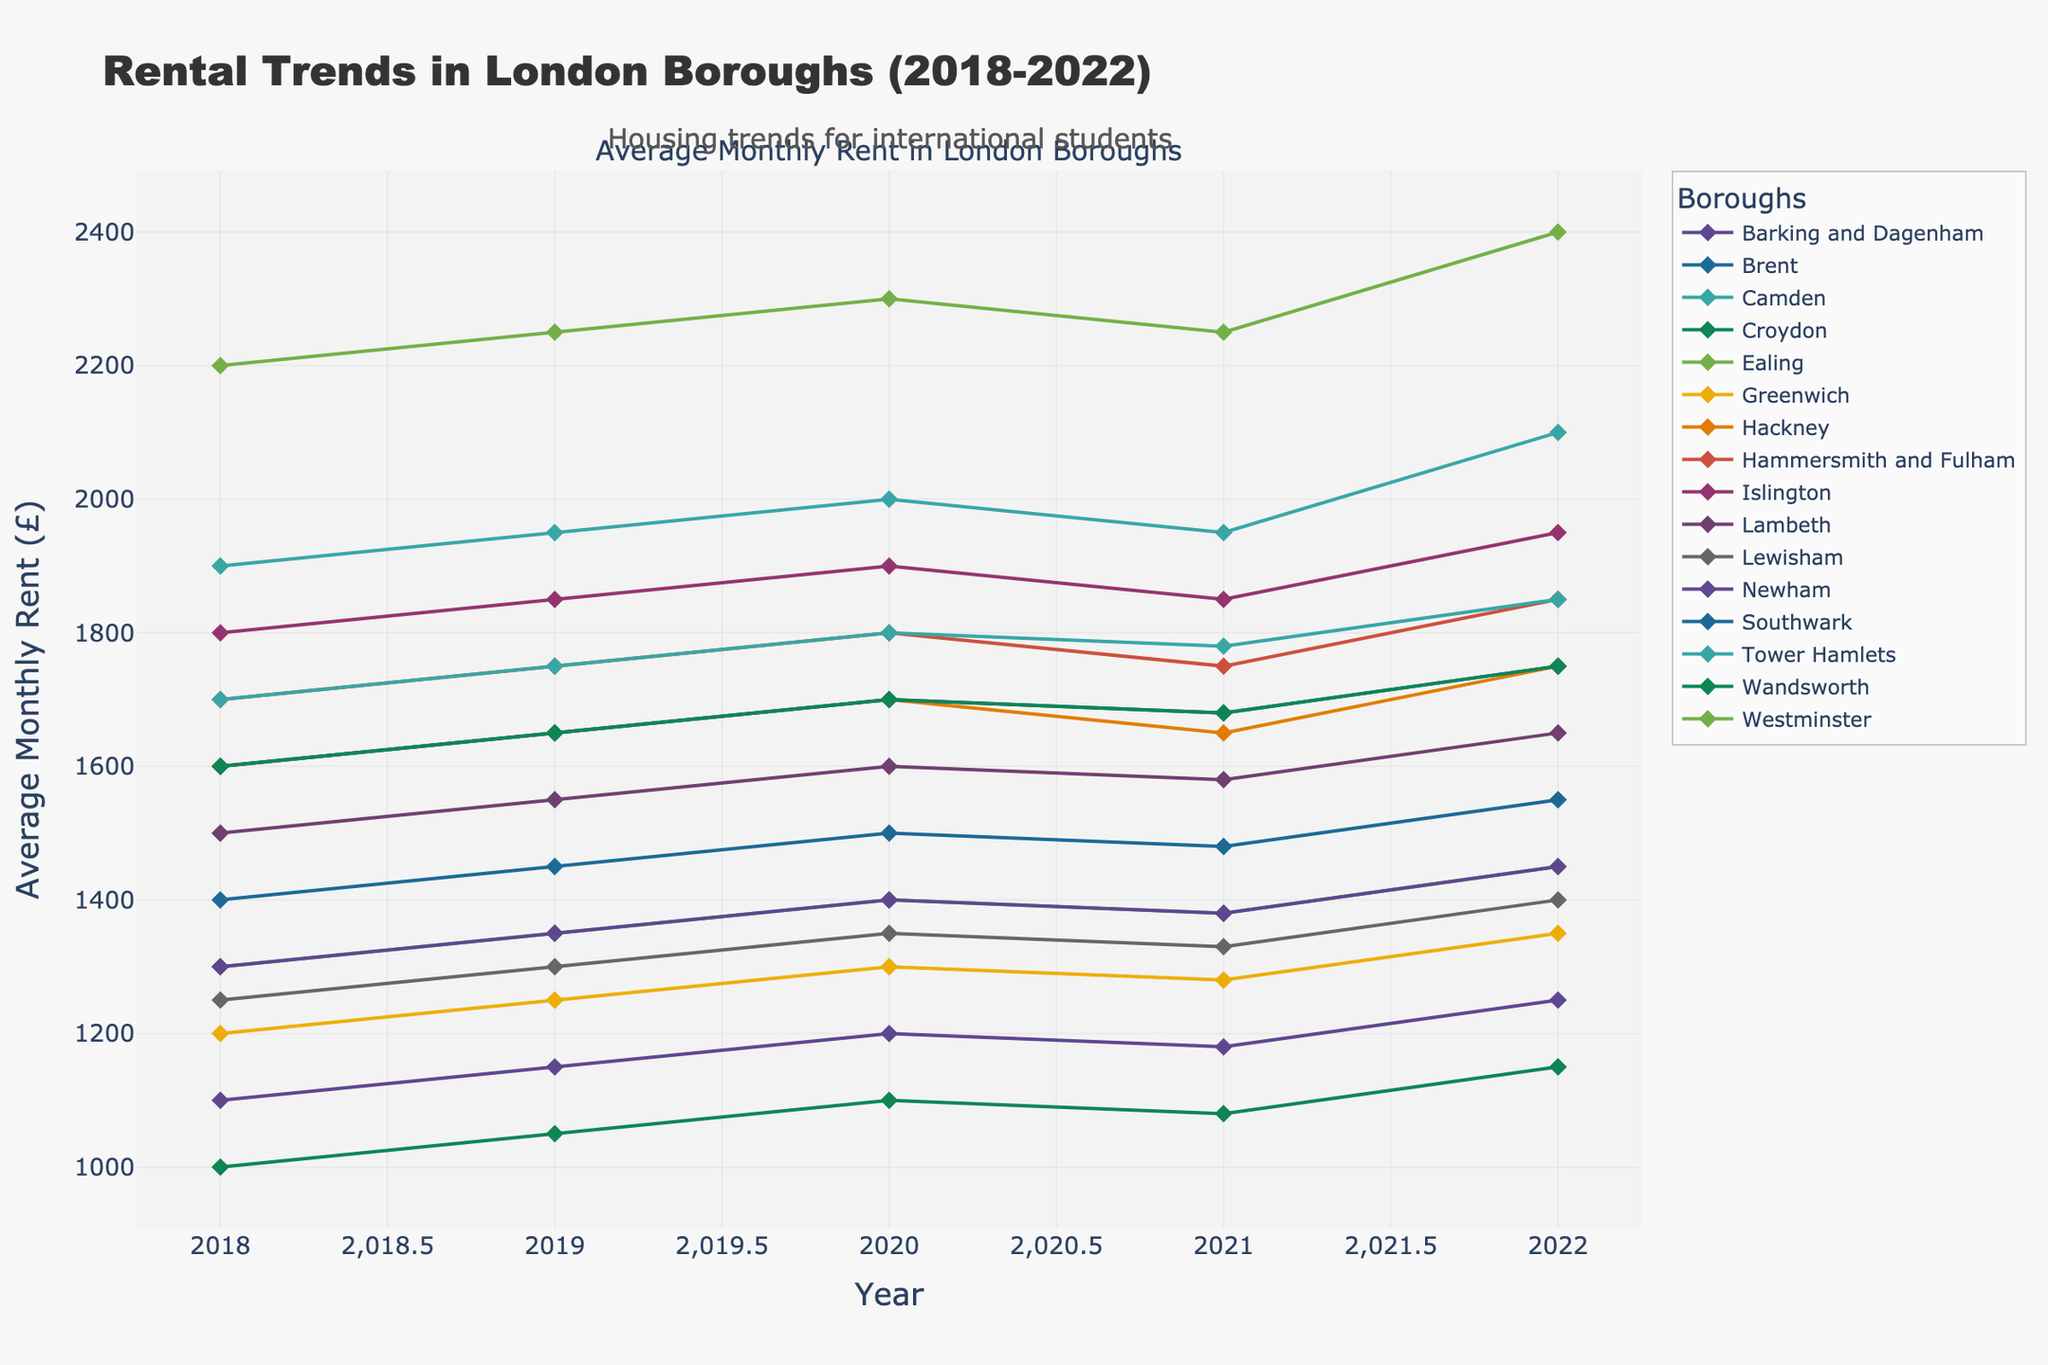Which borough had the highest average rent in 2022? The figure shows multiple lines corresponding to different boroughs. Identify the line for 2022 and look for the highest point on the y-axis. The highest point is for Westminster.
Answer: Westminster Which borough had the lowest average rent in 2020? The figure shows multiple lines corresponding to different boroughs. Identify the line for 2020 and look for the lowest point on the y-axis. The lowest point is for Croydon.
Answer: Croydon By how much did the rent in Camden increase from 2018 to 2022? Find the data points for Camden in 2018 and 2022 from the figure. Subtract the 2018 value from the 2022 value. Camden had an increase from 1900 to 2100.
Answer: 200 Which boroughs experienced a decrease in average monthly rent from 2020 to 2021? Look at the 2020 and 2021 data points for all boroughs. Identify the boroughs where the 2021 value is less than the 2020 value. Camden, Hammersmith and Fulham, Islington, Southwark, Wandsworth, Westminster showed decreases.
Answer: Camden, Hammersmith and Fulham, Islington, Southwark, Wandsworth, Westminster Which borough had the narrowest range of rent changes (difference between the highest and lowest rent) over the 5 years? Calculate the difference between the highest and lowest rent for all boroughs by observing the plot. Compare these differences. The smallest range is for Croydon.
Answer: Croydon What is the average rent across all boroughs for the year 2019? Sum the rents for all boroughs in 2019 and then divide by the number of boroughs (16). Sum = 1150+1450+1950+1050+1350+1250+1650+1750+1850+1550+1300+1350+1650+1750+1650+2250, total = 25100. Average = 25100/16.
Answer: 1568.75 By how much more did the rent in Westminster increase from 2018 to 2022 compared to the rent in Barking and Dagenham? Calculate the increase for each borough: Westminster (2400-2200) = 200, Barking and Dagenham (1250-1100) = 150. Subtract the increase of Barking and Dagenham from that of Westminster.
Answer: 50 Which borough had a consistent yearly rent increase without any year showing a rent decrease? Observe the plot and identify the boroughs where the trend is consistently upward each year. Barking and Dagenham, Brent, Camden fit this criterion.
Answer: Barking and Dagenham, Brent, Camden On average, did rents increase or decrease from 2021 to 2022 across all boroughs? For each borough, subtract the 2021 rent from the 2022 rent and sum these differences. If the total is positive, rents increased on average; if negative, they decreased. The plotted trends mostly show a positive increase from 2021 to 2022.
Answer: Increase 